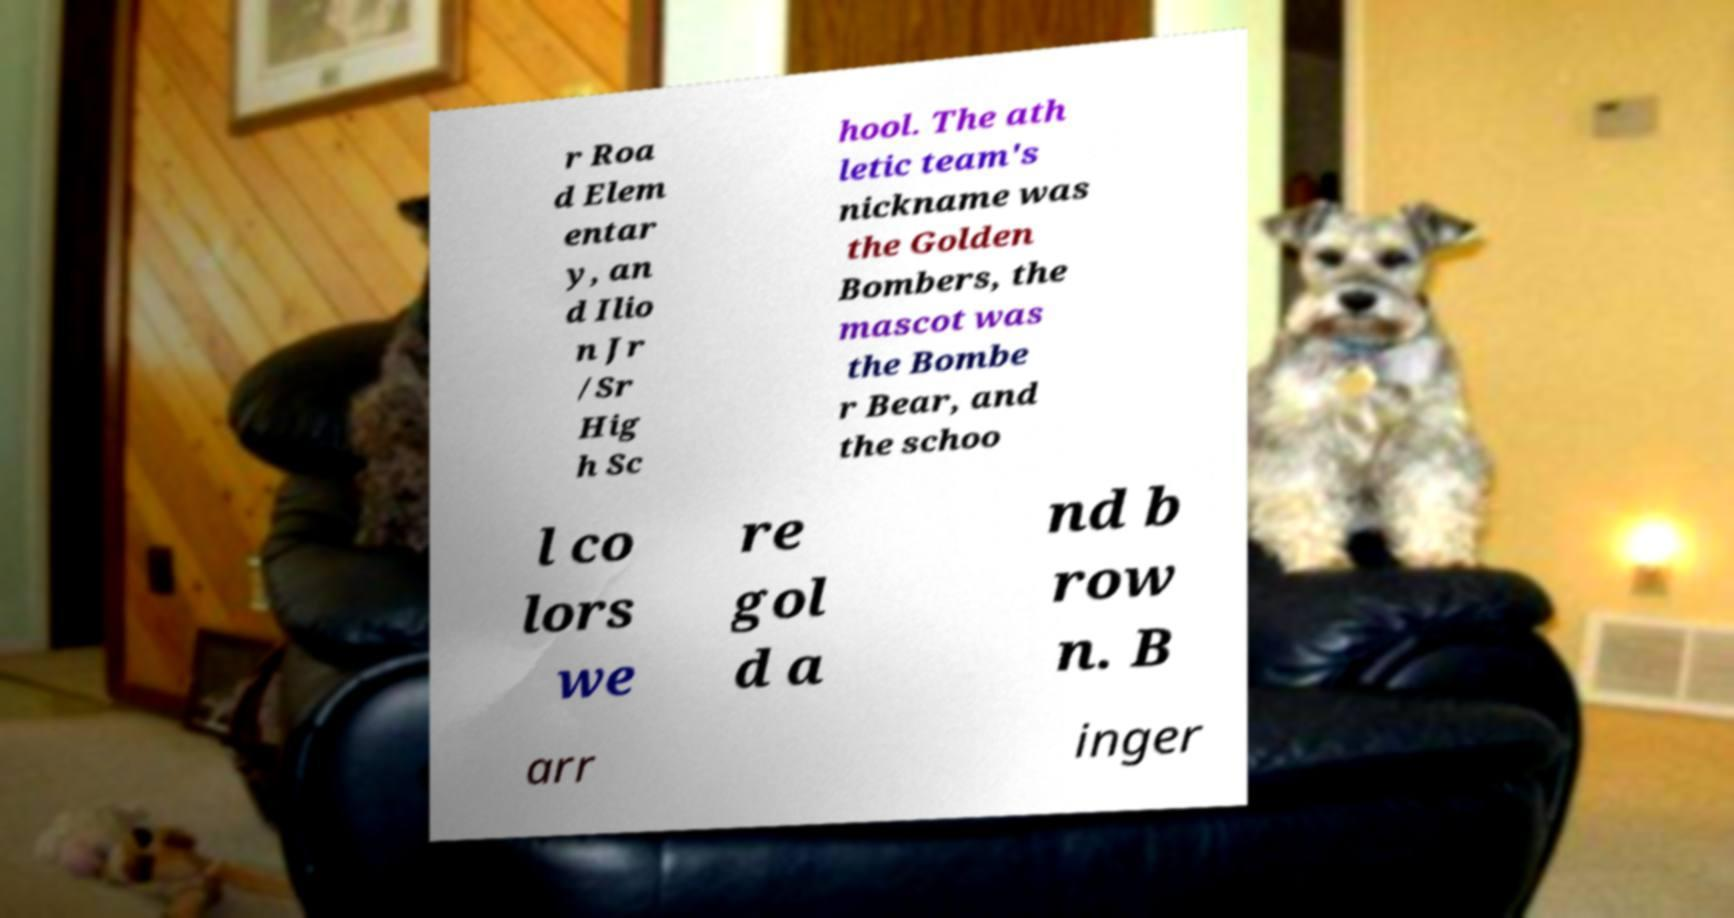What messages or text are displayed in this image? I need them in a readable, typed format. r Roa d Elem entar y, an d Ilio n Jr /Sr Hig h Sc hool. The ath letic team's nickname was the Golden Bombers, the mascot was the Bombe r Bear, and the schoo l co lors we re gol d a nd b row n. B arr inger 